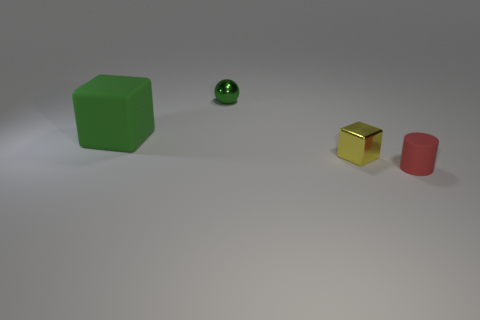Is there anything else that has the same size as the green rubber thing?
Your response must be concise. No. Is the number of rubber things greater than the number of metal spheres?
Offer a very short reply. Yes. Is there any other thing that has the same color as the small shiny sphere?
Your answer should be very brief. Yes. What shape is the other small object that is made of the same material as the small green thing?
Your answer should be very brief. Cube. The cube that is in front of the cube that is on the left side of the shiny cube is made of what material?
Your answer should be compact. Metal. Do the small metal object that is in front of the green ball and the tiny red thing have the same shape?
Give a very brief answer. No. Is the number of balls that are in front of the small green ball greater than the number of tiny matte things?
Provide a short and direct response. No. Is there anything else that is made of the same material as the red cylinder?
Give a very brief answer. Yes. There is a small object that is the same color as the big thing; what shape is it?
Provide a succinct answer. Sphere. How many cylinders are tiny yellow things or green matte objects?
Your response must be concise. 0. 